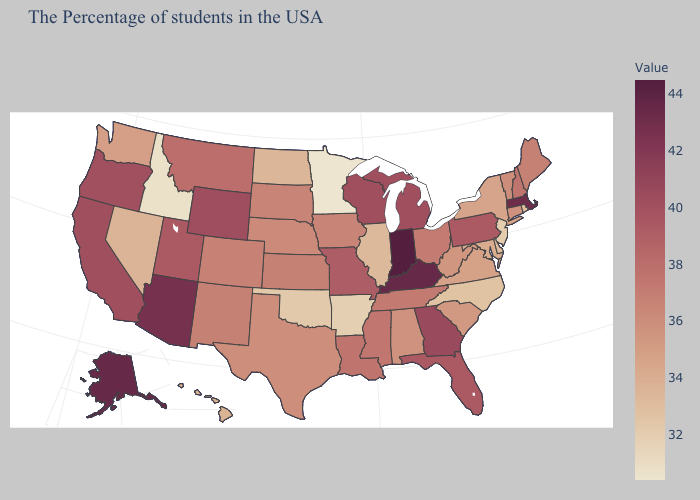Does the map have missing data?
Concise answer only. No. Does Indiana have the highest value in the USA?
Be succinct. Yes. Is the legend a continuous bar?
Keep it brief. Yes. Does New York have the highest value in the Northeast?
Answer briefly. No. Which states have the highest value in the USA?
Keep it brief. Indiana. Among the states that border Massachusetts , does New Hampshire have the highest value?
Keep it brief. Yes. 